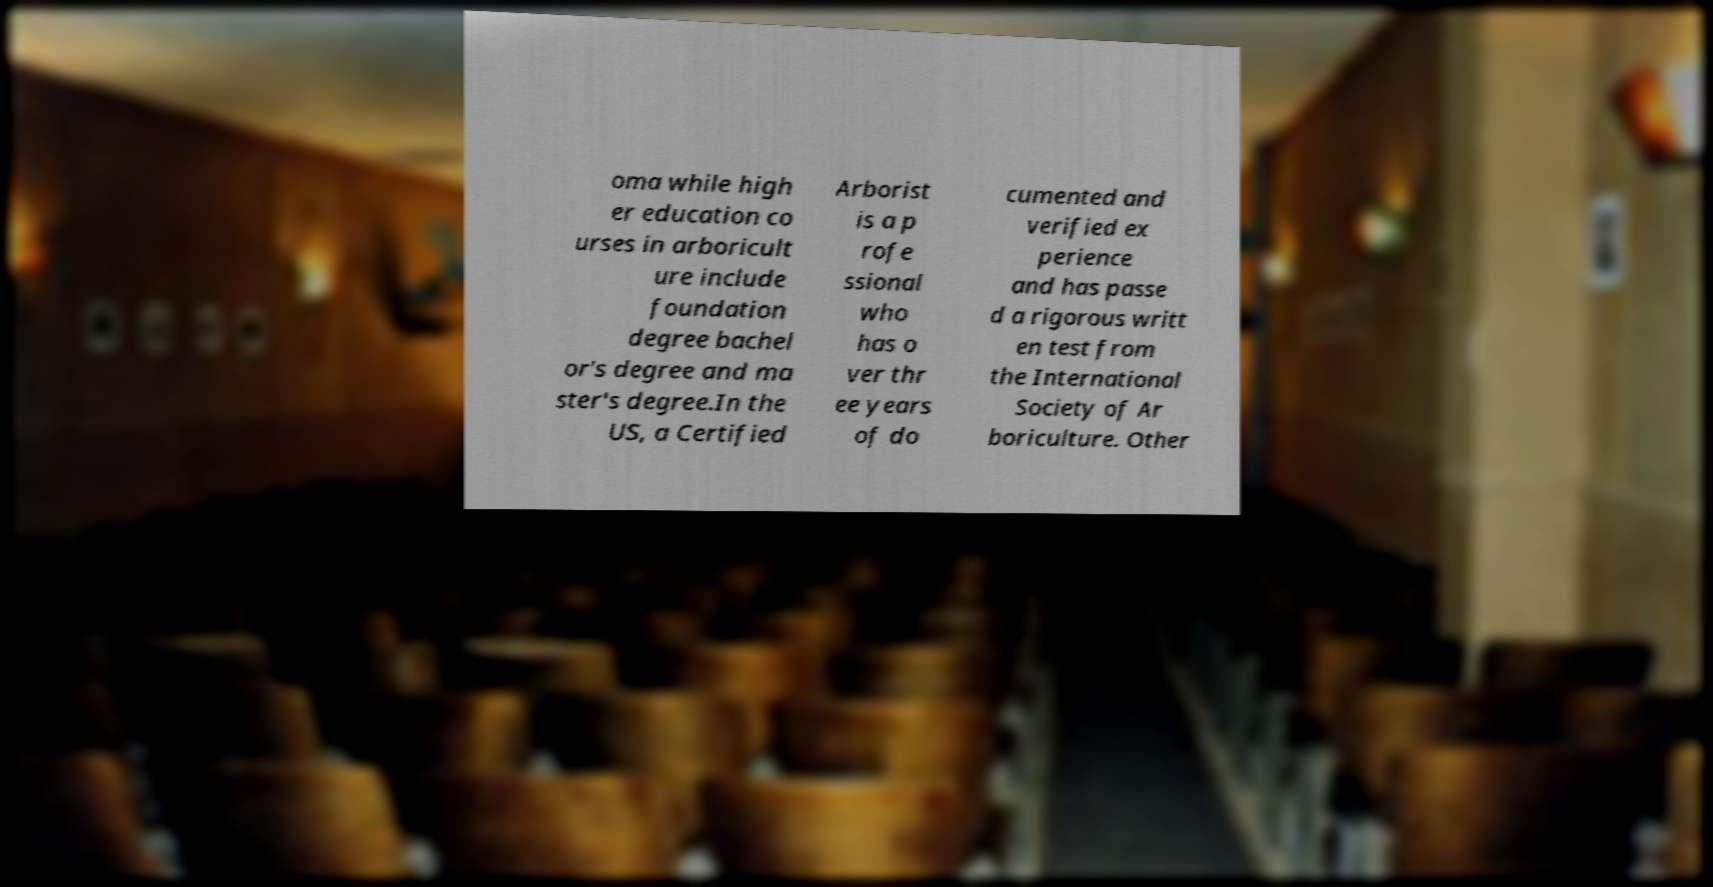Can you read and provide the text displayed in the image?This photo seems to have some interesting text. Can you extract and type it out for me? oma while high er education co urses in arboricult ure include foundation degree bachel or's degree and ma ster's degree.In the US, a Certified Arborist is a p rofe ssional who has o ver thr ee years of do cumented and verified ex perience and has passe d a rigorous writt en test from the International Society of Ar boriculture. Other 